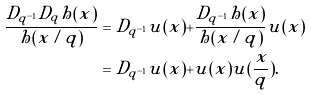Convert formula to latex. <formula><loc_0><loc_0><loc_500><loc_500>\frac { D _ { q ^ { - 1 } } D _ { q } h ( x ) } { h ( x / q ) } & = D _ { q ^ { - 1 } } u ( x ) + \frac { D _ { q ^ { - 1 } } h ( x ) } { h ( x / q ) } u ( x ) \\ & = D _ { q ^ { - 1 } } u ( x ) + u ( x ) u ( \frac { x } { q } ) .</formula> 